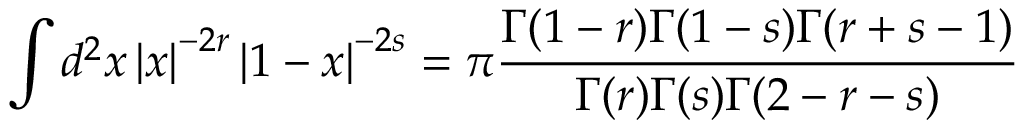<formula> <loc_0><loc_0><loc_500><loc_500>\int d ^ { 2 } x \left | x \right | ^ { - 2 r } \left | 1 - x \right | ^ { - 2 s } = \pi \frac { \Gamma ( 1 - r ) \Gamma ( 1 - s ) \Gamma ( r + s - 1 ) } { \Gamma ( r ) \Gamma ( s ) \Gamma ( 2 - r - s ) }</formula> 